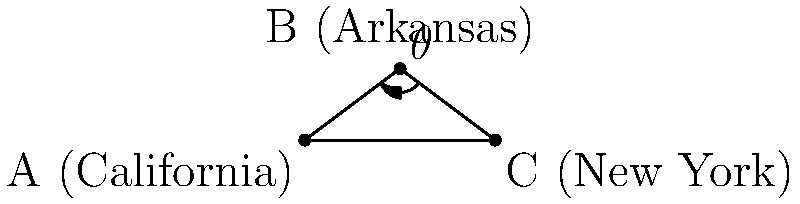In the map of the United States represented by the triangle ABC, where A is California, B is Arkansas, and C is New York, the angle $\theta$ at point B represents the trajectory of Japanese-American internment camps during World War II. If the distance AC is 8 units and the height of the triangle from B to AC is 3 units, what is the measure of angle $\theta$ in degrees? To find the measure of angle $\theta$, we can follow these steps:

1) First, we need to find the lengths of AB and BC using the Pythagorean theorem.

2) For AB:
   $AB^2 = 4^2 + 3^2 = 16 + 9 = 25$
   $AB = 5$ units

3) For BC:
   $BC^2 = 4^2 + 3^2 = 16 + 9 = 25$
   $BC = 5$ units

4) Now we have an isosceles triangle with AB = BC = 5 and AC = 8.

5) We can split this isosceles triangle into two right triangles by drawing a height from B to AC.

6) In one of these right triangles:
   - The hypotenuse is 5
   - The height is 3
   - Half of AC is 4

7) We can use the inverse cosine function to find half of angle $\theta$:
   $\cos(\frac{\theta}{2}) = \frac{4}{5}$

8) Therefore:
   $\frac{\theta}{2} = \arccos(\frac{4}{5})$

9) $\theta = 2 \arccos(\frac{4}{5})$

10) Using a calculator or computer:
    $\theta \approx 78.46°$
Answer: $78.46°$ 